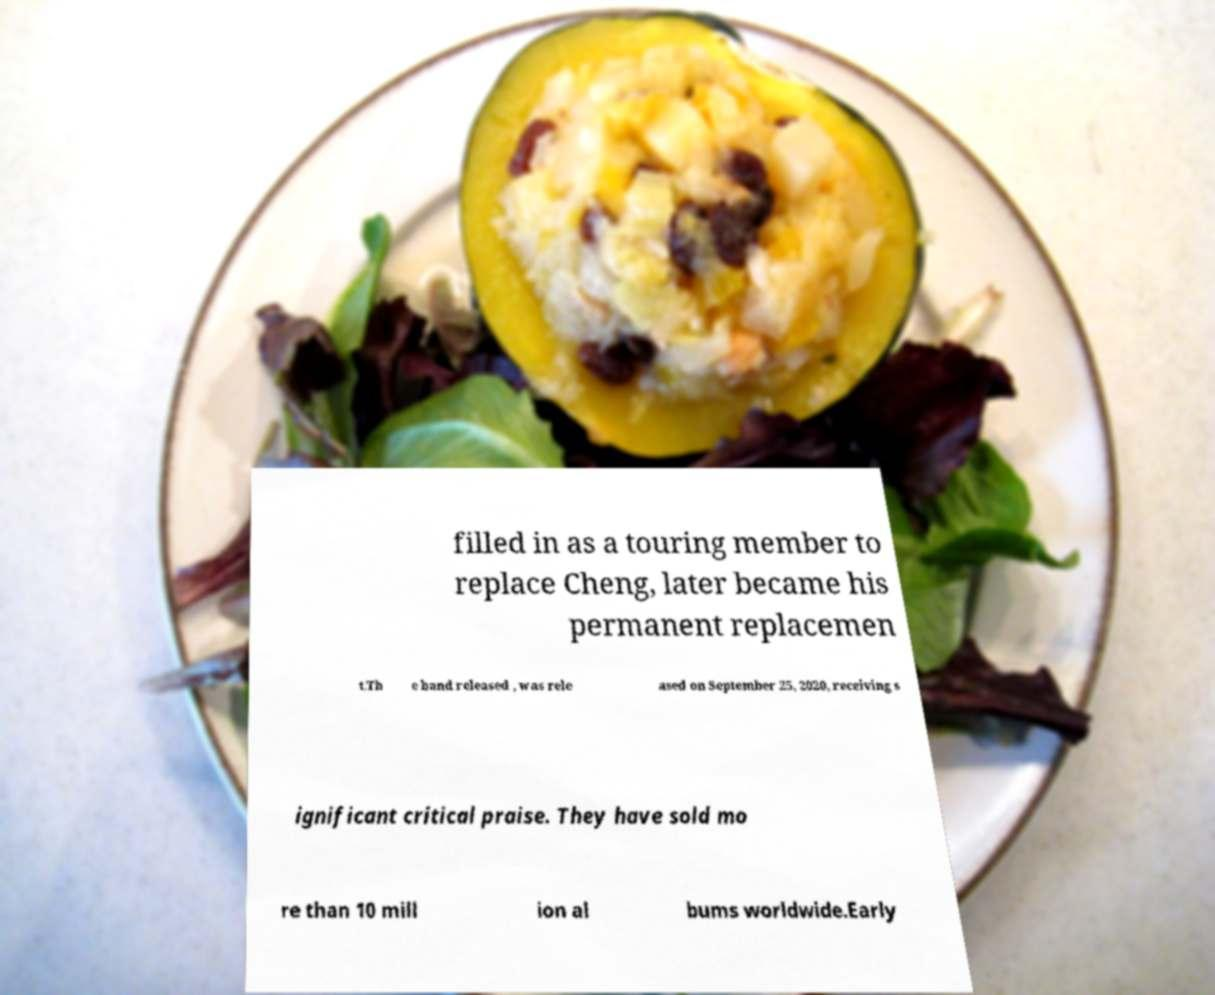What messages or text are displayed in this image? I need them in a readable, typed format. filled in as a touring member to replace Cheng, later became his permanent replacemen t.Th e band released , was rele ased on September 25, 2020, receiving s ignificant critical praise. They have sold mo re than 10 mill ion al bums worldwide.Early 